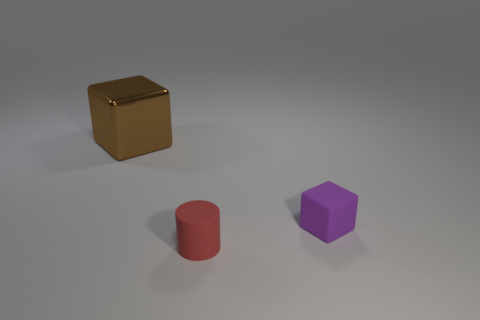Subtract all cyan cylinders. Subtract all cyan cubes. How many cylinders are left? 1 Add 3 gray shiny objects. How many objects exist? 6 Subtract all cylinders. How many objects are left? 2 Add 1 small cyan metal blocks. How many small cyan metal blocks exist? 1 Subtract 0 gray balls. How many objects are left? 3 Subtract all shiny objects. Subtract all small purple matte cubes. How many objects are left? 1 Add 1 tiny cubes. How many tiny cubes are left? 2 